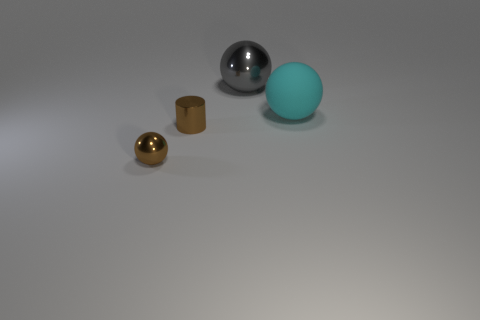Add 2 matte balls. How many objects exist? 6 Subtract all balls. How many objects are left? 1 Subtract all big metal objects. Subtract all big cyan matte spheres. How many objects are left? 2 Add 1 shiny cylinders. How many shiny cylinders are left? 2 Add 3 cyan metallic blocks. How many cyan metallic blocks exist? 3 Subtract 0 blue cylinders. How many objects are left? 4 